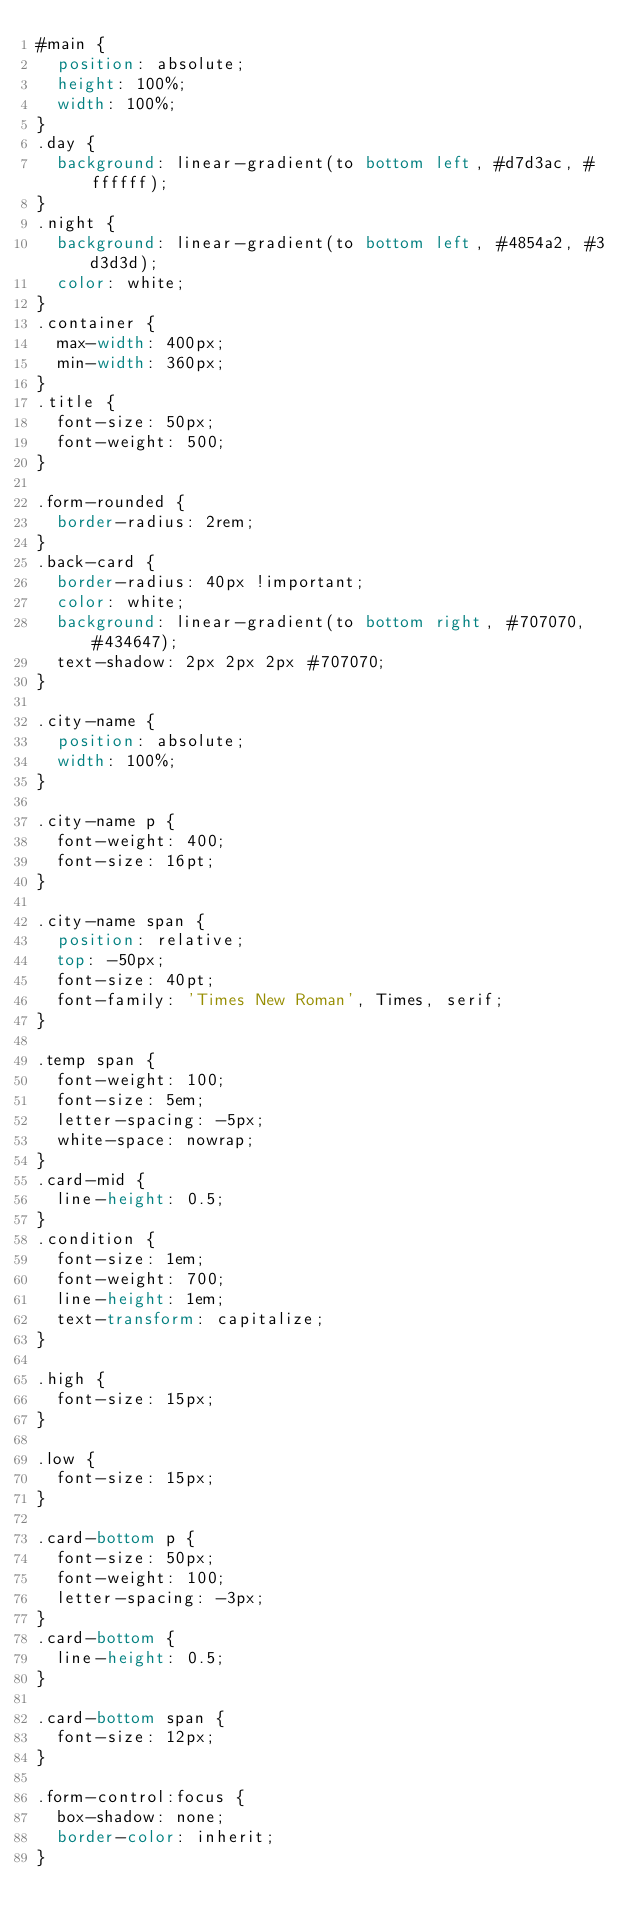<code> <loc_0><loc_0><loc_500><loc_500><_CSS_>#main {
  position: absolute;
  height: 100%;
  width: 100%;
}
.day {
  background: linear-gradient(to bottom left, #d7d3ac, #ffffff);
}
.night {
  background: linear-gradient(to bottom left, #4854a2, #3d3d3d);
  color: white;
}
.container {
  max-width: 400px;
  min-width: 360px;
}
.title {
  font-size: 50px;
  font-weight: 500;
}

.form-rounded {
  border-radius: 2rem;
}
.back-card {
  border-radius: 40px !important;
  color: white;
  background: linear-gradient(to bottom right, #707070, #434647);
  text-shadow: 2px 2px 2px #707070;
}

.city-name {
  position: absolute;
  width: 100%;
}

.city-name p {
  font-weight: 400;
  font-size: 16pt;
}

.city-name span {
  position: relative;
  top: -50px;
  font-size: 40pt;
  font-family: 'Times New Roman', Times, serif;
}

.temp span {
  font-weight: 100;
  font-size: 5em;
  letter-spacing: -5px;
  white-space: nowrap;
}
.card-mid {
  line-height: 0.5;
}
.condition {
  font-size: 1em;
  font-weight: 700;
  line-height: 1em;
  text-transform: capitalize;
}

.high {
  font-size: 15px;
}

.low {
  font-size: 15px;
}

.card-bottom p {
  font-size: 50px;
  font-weight: 100;
  letter-spacing: -3px;
}
.card-bottom {
  line-height: 0.5;
}

.card-bottom span {
  font-size: 12px;
}

.form-control:focus {
  box-shadow: none;
  border-color: inherit;
}
</code> 